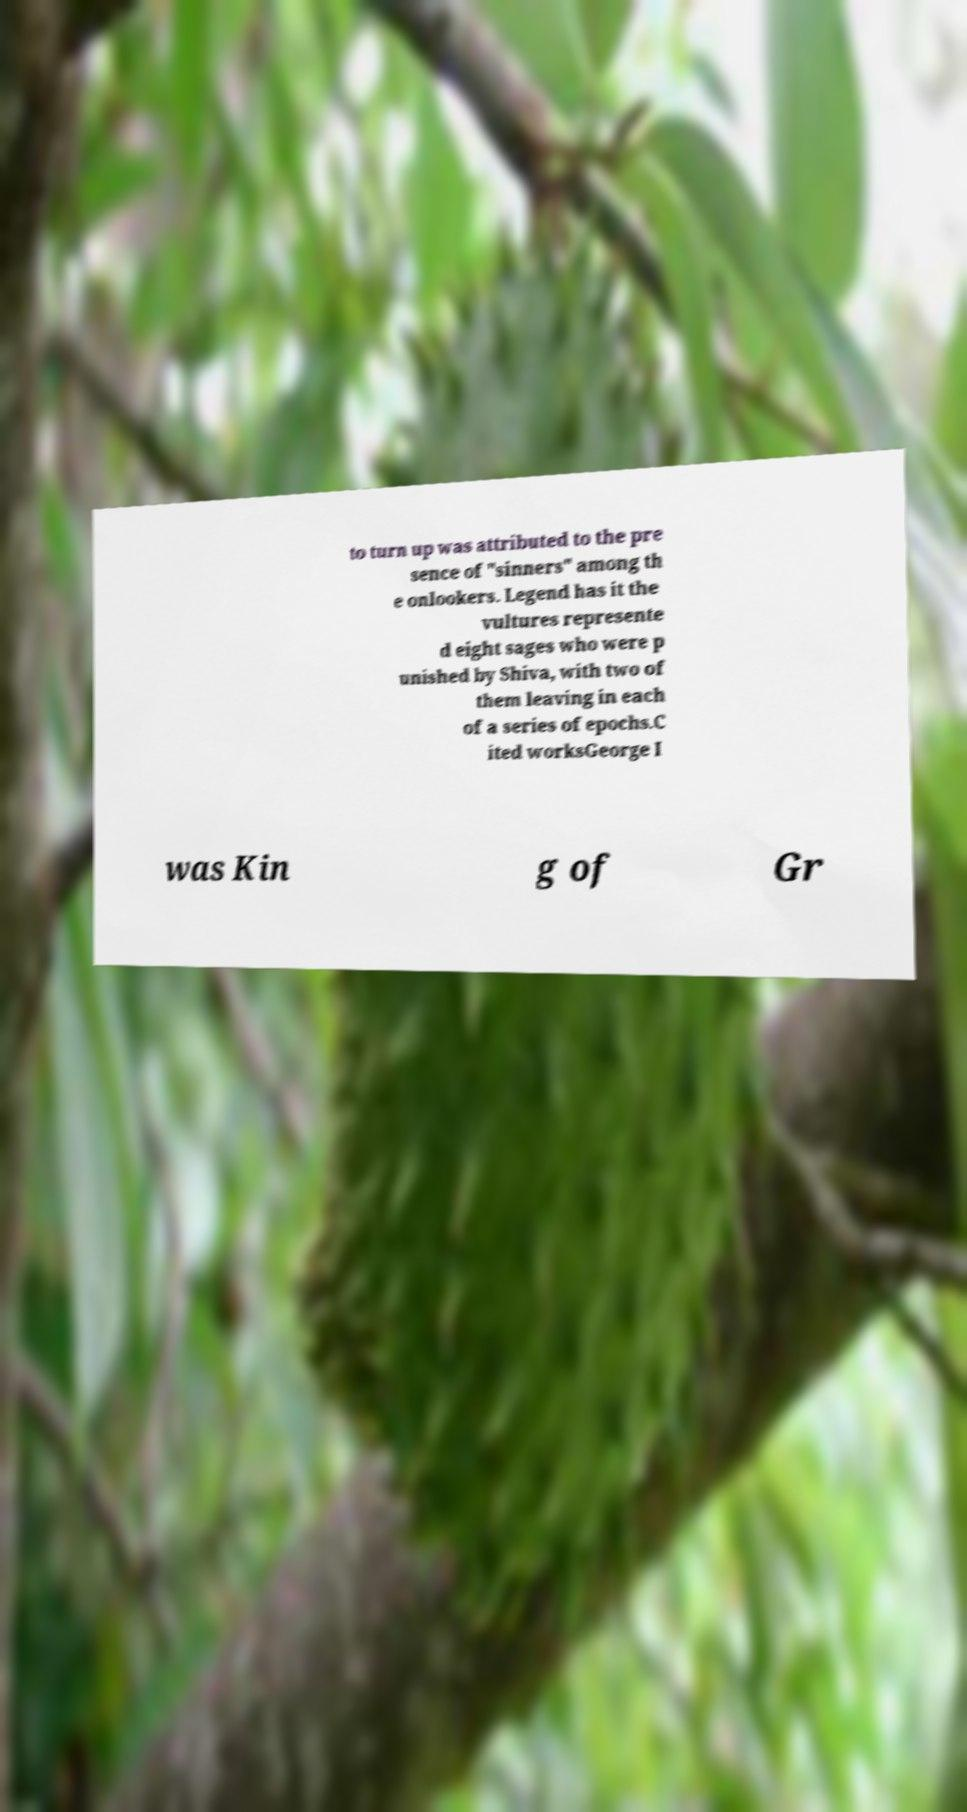Can you accurately transcribe the text from the provided image for me? to turn up was attributed to the pre sence of "sinners" among th e onlookers. Legend has it the vultures represente d eight sages who were p unished by Shiva, with two of them leaving in each of a series of epochs.C ited worksGeorge I was Kin g of Gr 